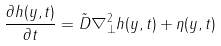<formula> <loc_0><loc_0><loc_500><loc_500>\frac { \partial h ( y , t ) } { \partial t } = \tilde { D } \nabla _ { \perp } ^ { 2 } h ( y , t ) + \eta ( y , t )</formula> 